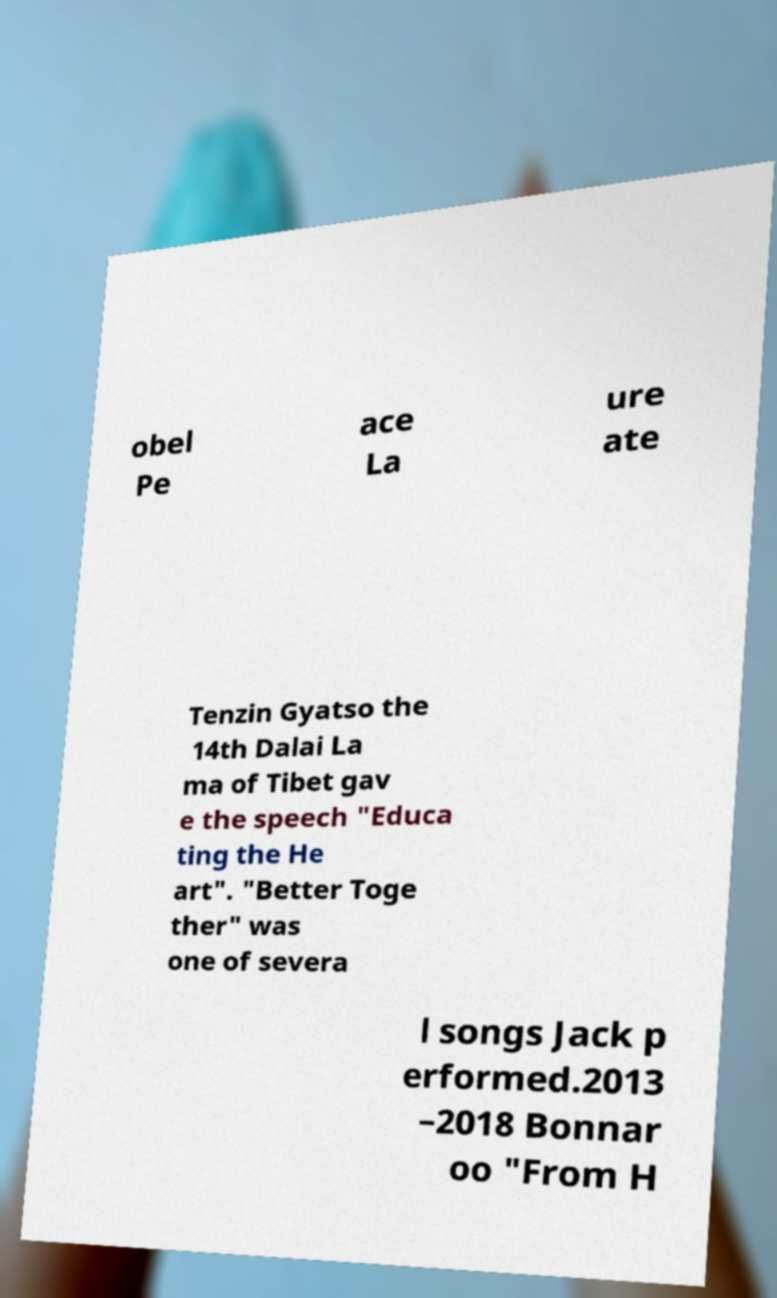What messages or text are displayed in this image? I need them in a readable, typed format. obel Pe ace La ure ate Tenzin Gyatso the 14th Dalai La ma of Tibet gav e the speech "Educa ting the He art". "Better Toge ther" was one of severa l songs Jack p erformed.2013 –2018 Bonnar oo "From H 